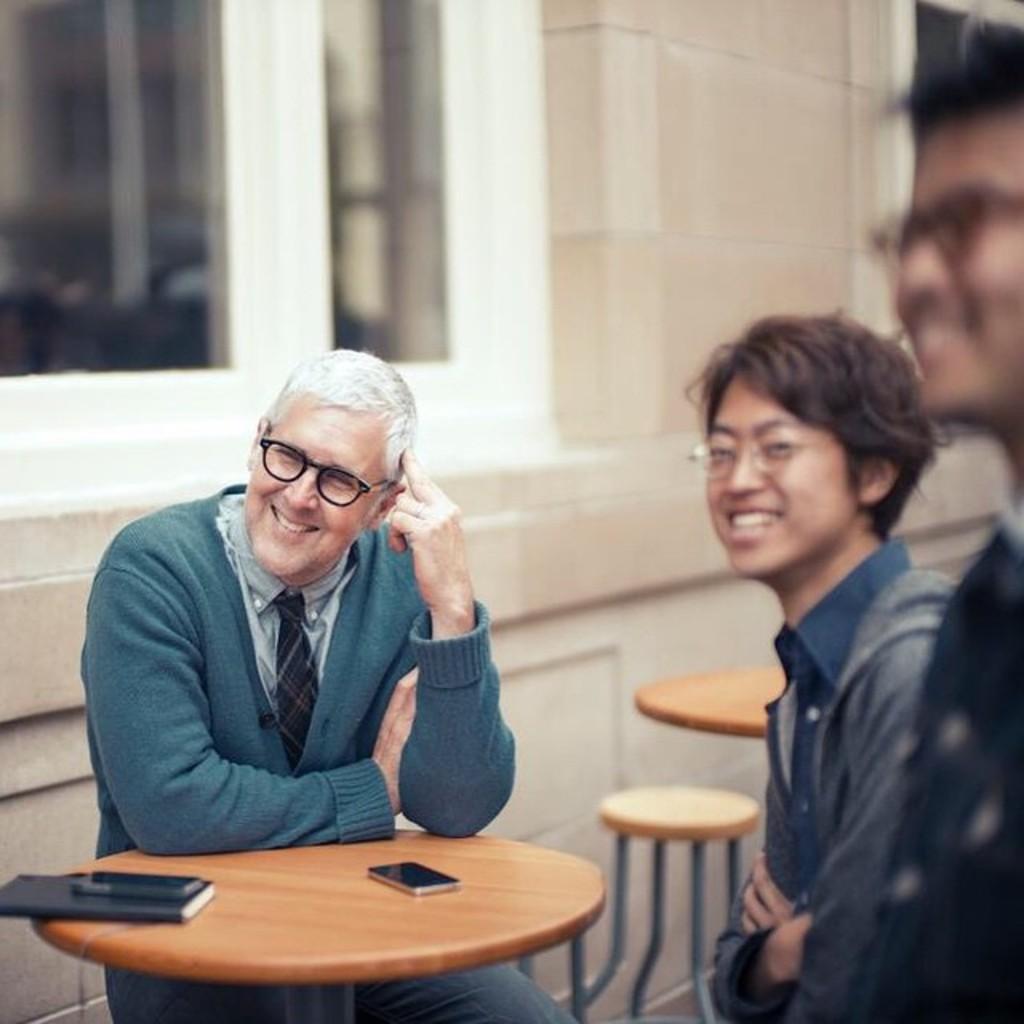In one or two sentences, can you explain what this image depicts? there are 3 people in this image. a person is sitting on a chair. in front of him there is a table on which there is a phone and a book. he is wearing a tie. behind him there is a building. 